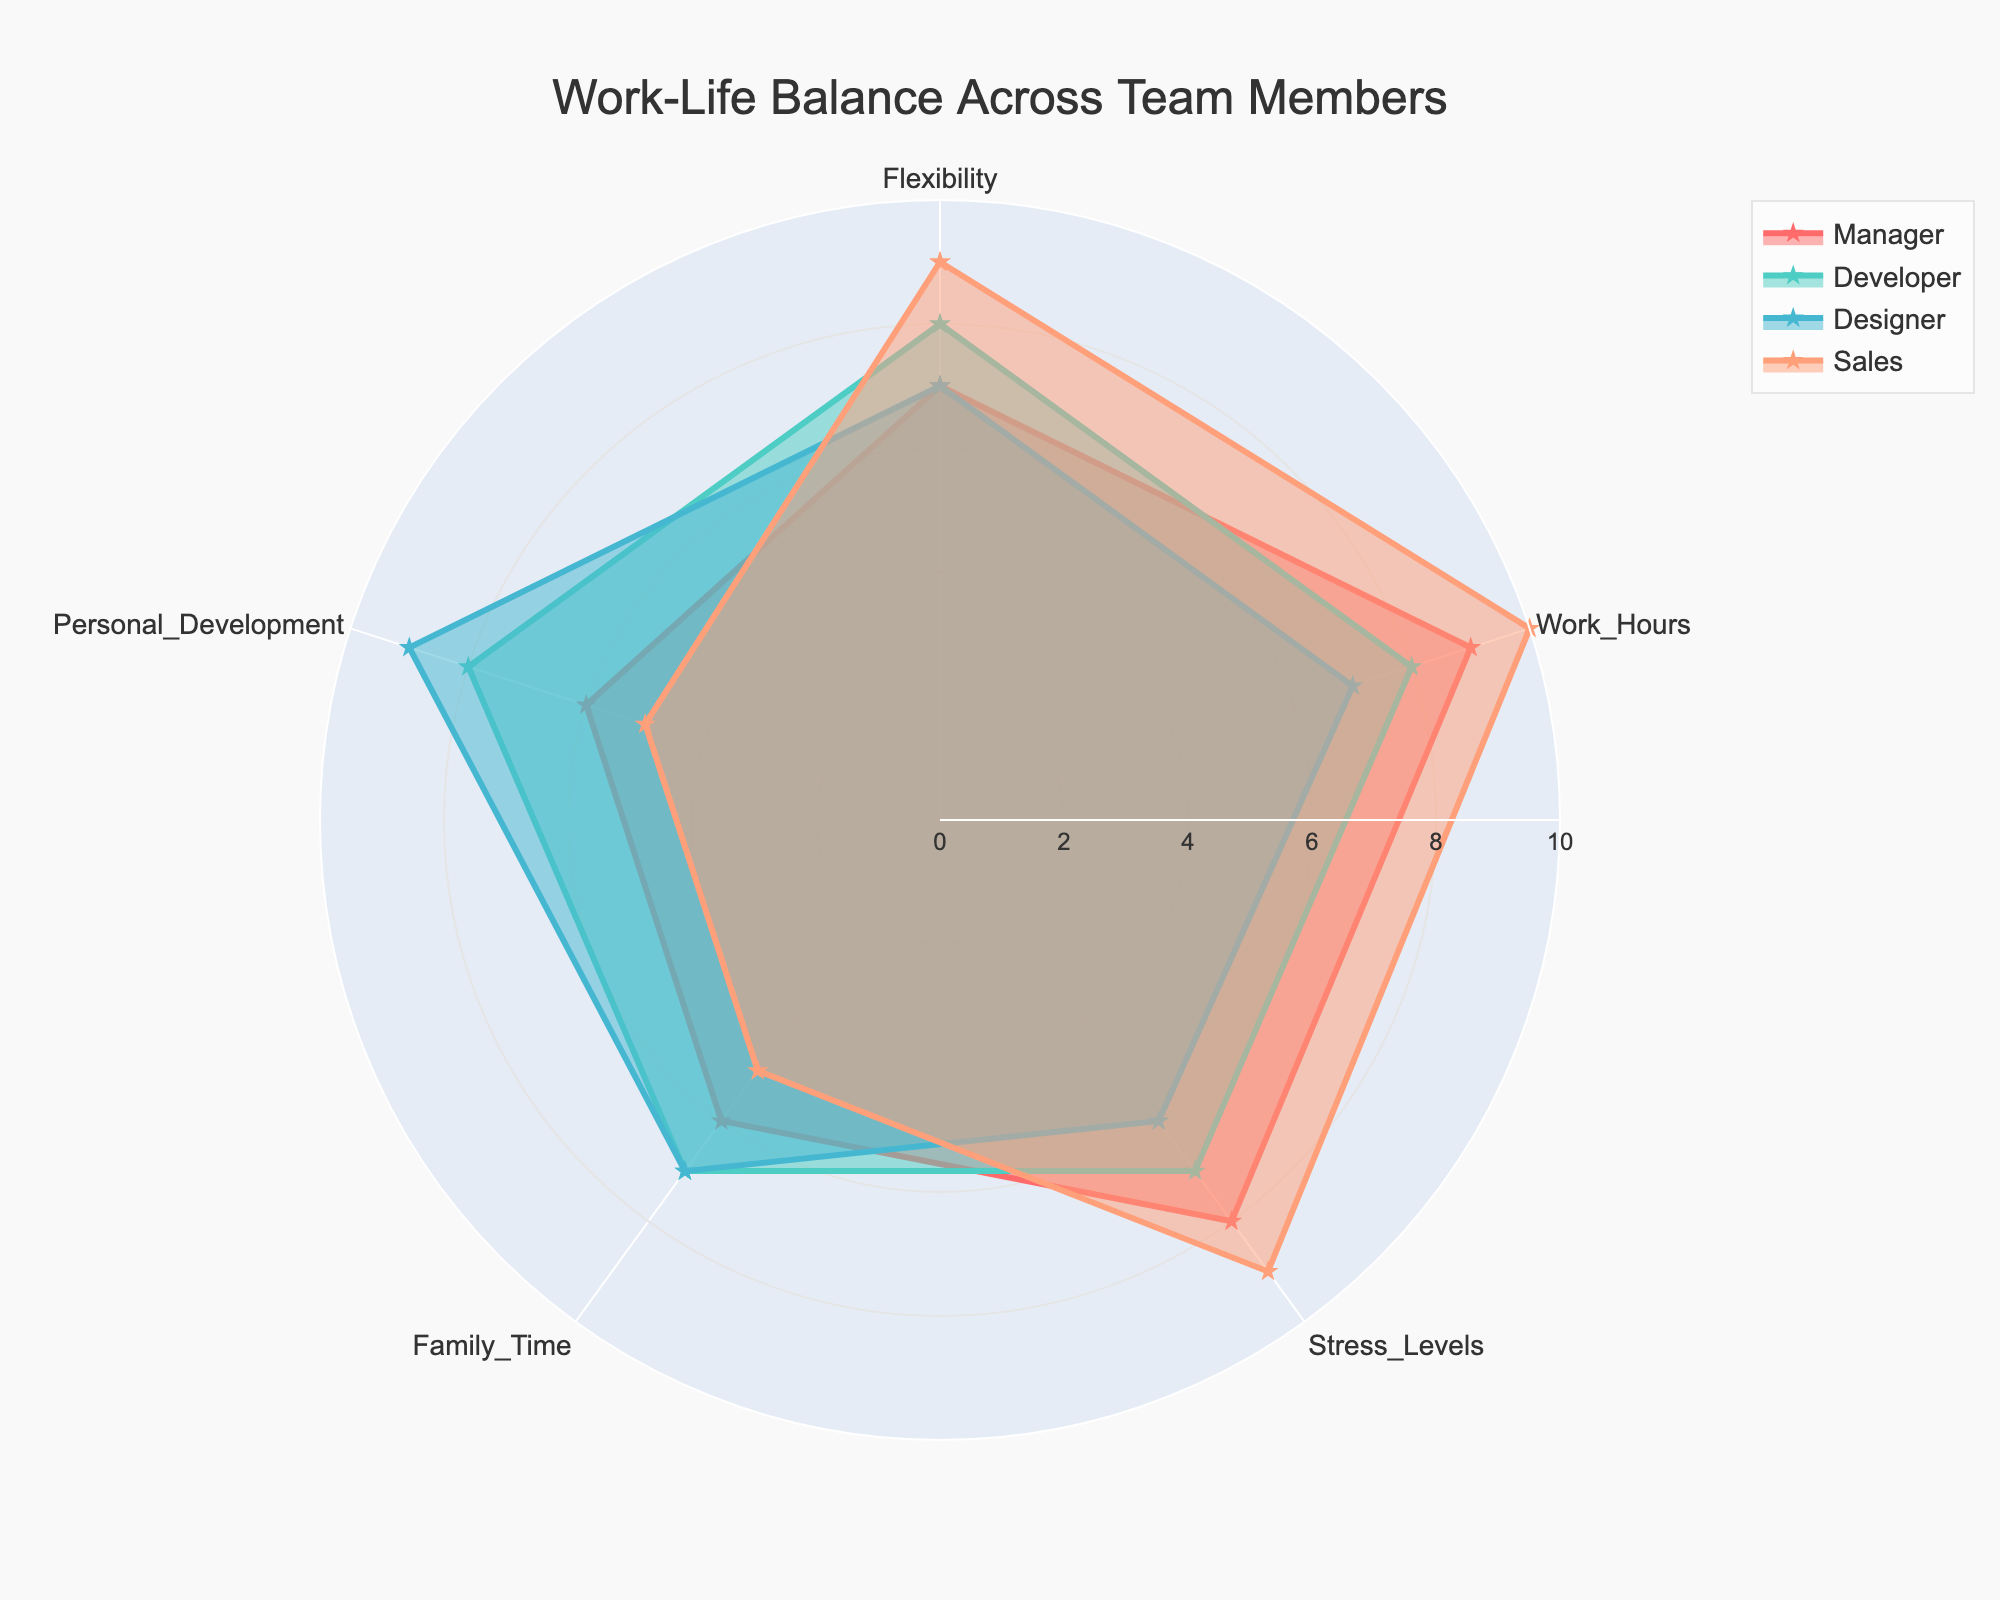What is the title of the radar chart? The title of the radar chart is typically placed at the top of the chart. It reads "Work-Life Balance Across Team Members"
Answer: Work-Life Balance Across Team Members Which role has the highest score for Work Hours? To find the role with the highest score for Work Hours, look at the segment of the radar chart that represents Work Hours and identify the role with the longest line extending from the center. Sales has the highest score of 10.
Answer: Sales What is the average Flexibility score across all roles? To calculate the average Flexibility score, sum the Flexibility scores for all roles (7 for Manager, 8 for Developer, 7 for Designer, 9 for Sales) and then divide by the number of roles (4). The total is 31, and the average is 31/4.
Answer: 7.75 Which two roles have the most similar patterns in their scores? Visually compare the shapes of the radar plots for each role. The Developer and Designer roles have a very similar shape, indicating similar patterns in their scores.
Answer: Developer and Designer What is the biggest difference in scores for Family Time between any two roles? Identify the Family Time scores for all roles (6 for Manager, 7 for Developer, 7 for Designer, 5 for Sales) and find the maximum difference between two scores. The biggest difference is between Developer/Designer (7) and Sales (5) which is 7 - 5.
Answer: 2 Which role has the lowest score for Personal Development? Look at the segment of the radar chart representing Personal Development and identify the role with the shortest line extending from the center. Sales has the lowest score of 5.
Answer: Sales How does the Stress Levels score for the Manager compare to that of the Developer? Compare the Stress Levels scores for the Manager (8) and the Developer (7). The Manager has a higher score than the Developer by 1.
Answer: Manager has a higher score by 1 What is the total score for the Designer across all categories? Sum the scores for Flexibility (7), Work Hours (7), Stress Levels (6), Family Time (7), and Personal Development (9) for the Designer. The total is 7 + 7 + 6 + 7 + 9 = 36.
Answer: 36 Which role scores highest in both Flexibility and Stress Levels? Identify the highest scores in both Flexibility (Sales with 9) and Stress Levels (Sales with 9). Both highest scores are held by Sales.
Answer: Sales Is there any role that has the same score in more than two categories? Review each role's scores across all five categories to find any role with the same score in more than two categories. No role has the same score in more than two categories.
Answer: No 